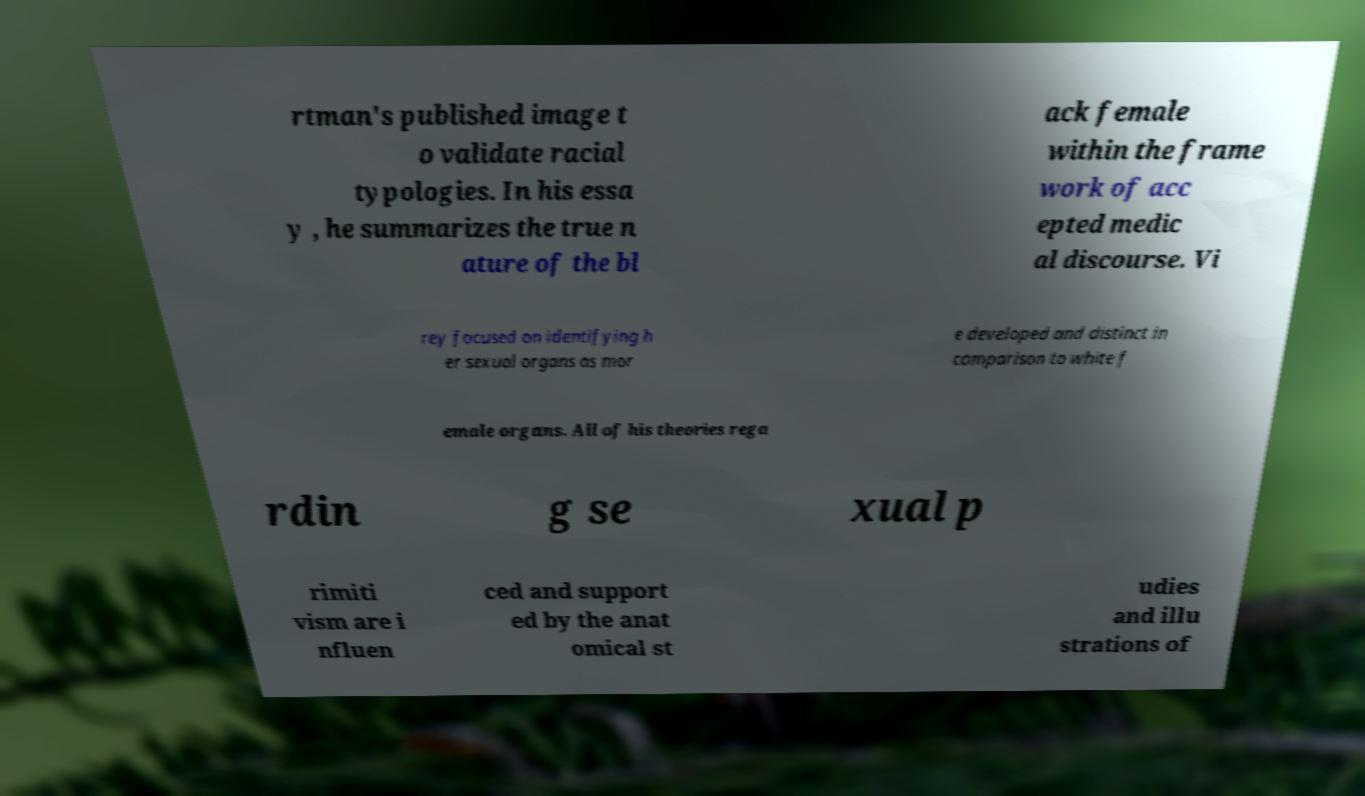Can you accurately transcribe the text from the provided image for me? rtman's published image t o validate racial typologies. In his essa y , he summarizes the true n ature of the bl ack female within the frame work of acc epted medic al discourse. Vi rey focused on identifying h er sexual organs as mor e developed and distinct in comparison to white f emale organs. All of his theories rega rdin g se xual p rimiti vism are i nfluen ced and support ed by the anat omical st udies and illu strations of 